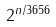Convert formula to latex. <formula><loc_0><loc_0><loc_500><loc_500>2 ^ { n / 3 6 5 6 }</formula> 